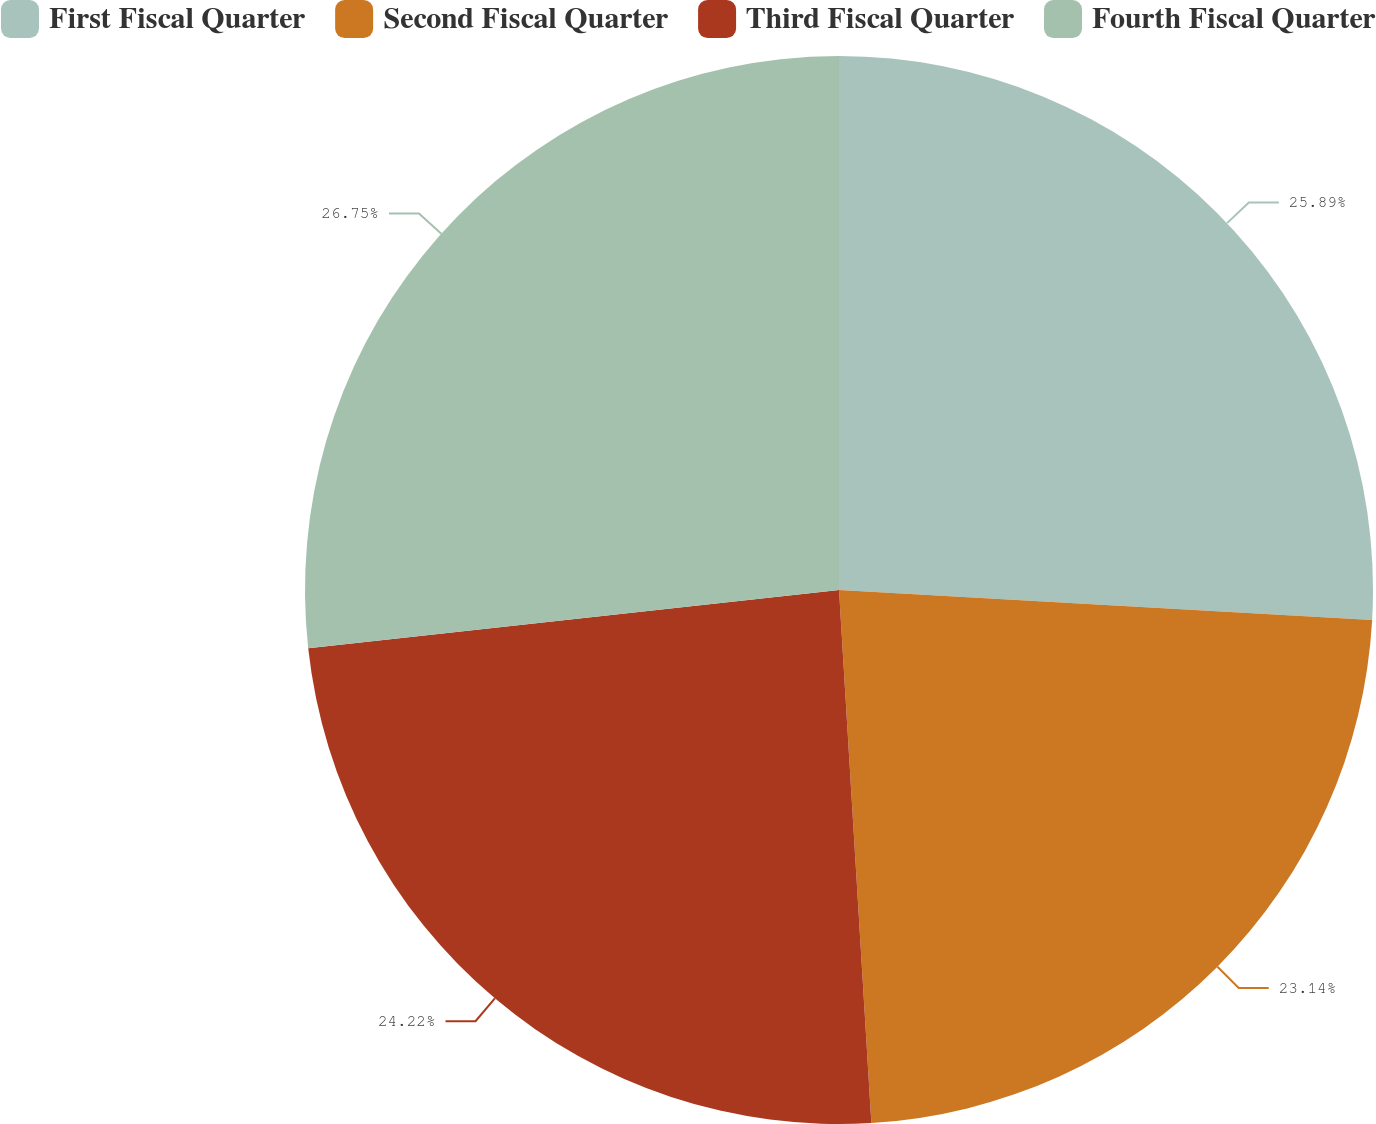Convert chart. <chart><loc_0><loc_0><loc_500><loc_500><pie_chart><fcel>First Fiscal Quarter<fcel>Second Fiscal Quarter<fcel>Third Fiscal Quarter<fcel>Fourth Fiscal Quarter<nl><fcel>25.89%<fcel>23.14%<fcel>24.22%<fcel>26.74%<nl></chart> 